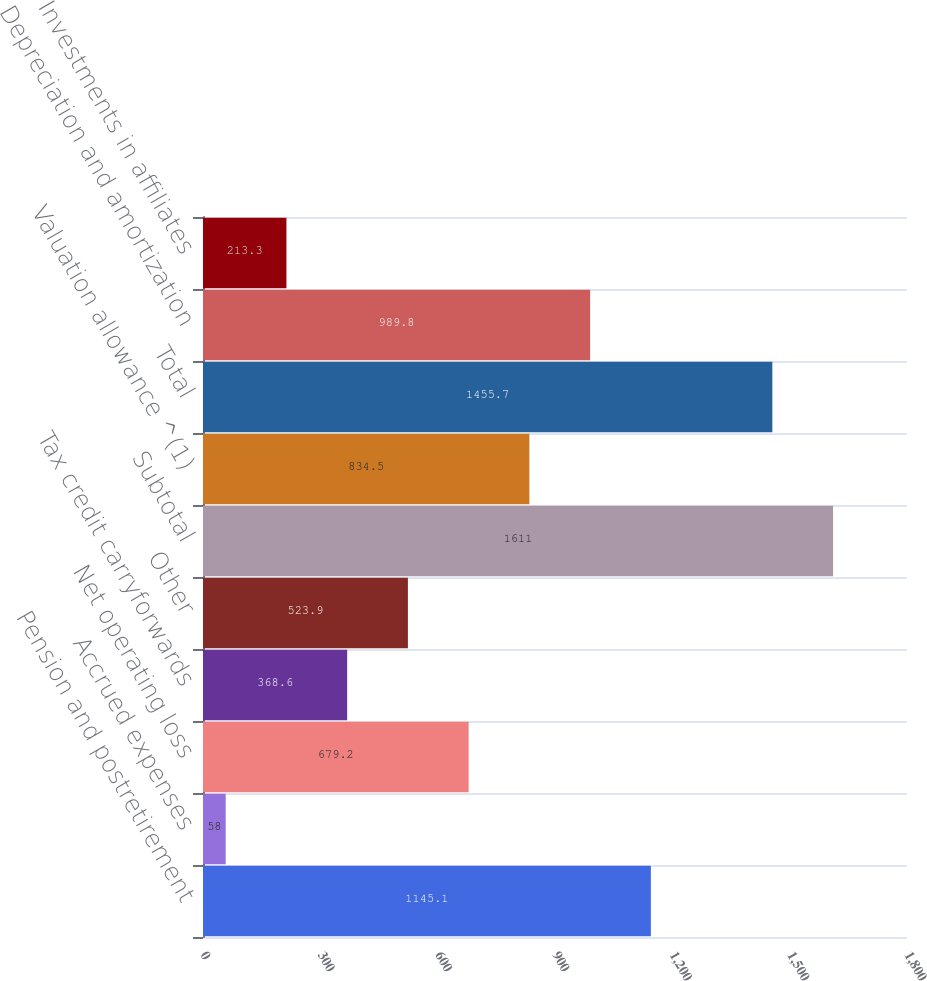Convert chart. <chart><loc_0><loc_0><loc_500><loc_500><bar_chart><fcel>Pension and postretirement<fcel>Accrued expenses<fcel>Net operating loss<fcel>Tax credit carryforwards<fcel>Other<fcel>Subtotal<fcel>Valuation allowance ^(1)<fcel>Total<fcel>Depreciation and amortization<fcel>Investments in affiliates<nl><fcel>1145.1<fcel>58<fcel>679.2<fcel>368.6<fcel>523.9<fcel>1611<fcel>834.5<fcel>1455.7<fcel>989.8<fcel>213.3<nl></chart> 